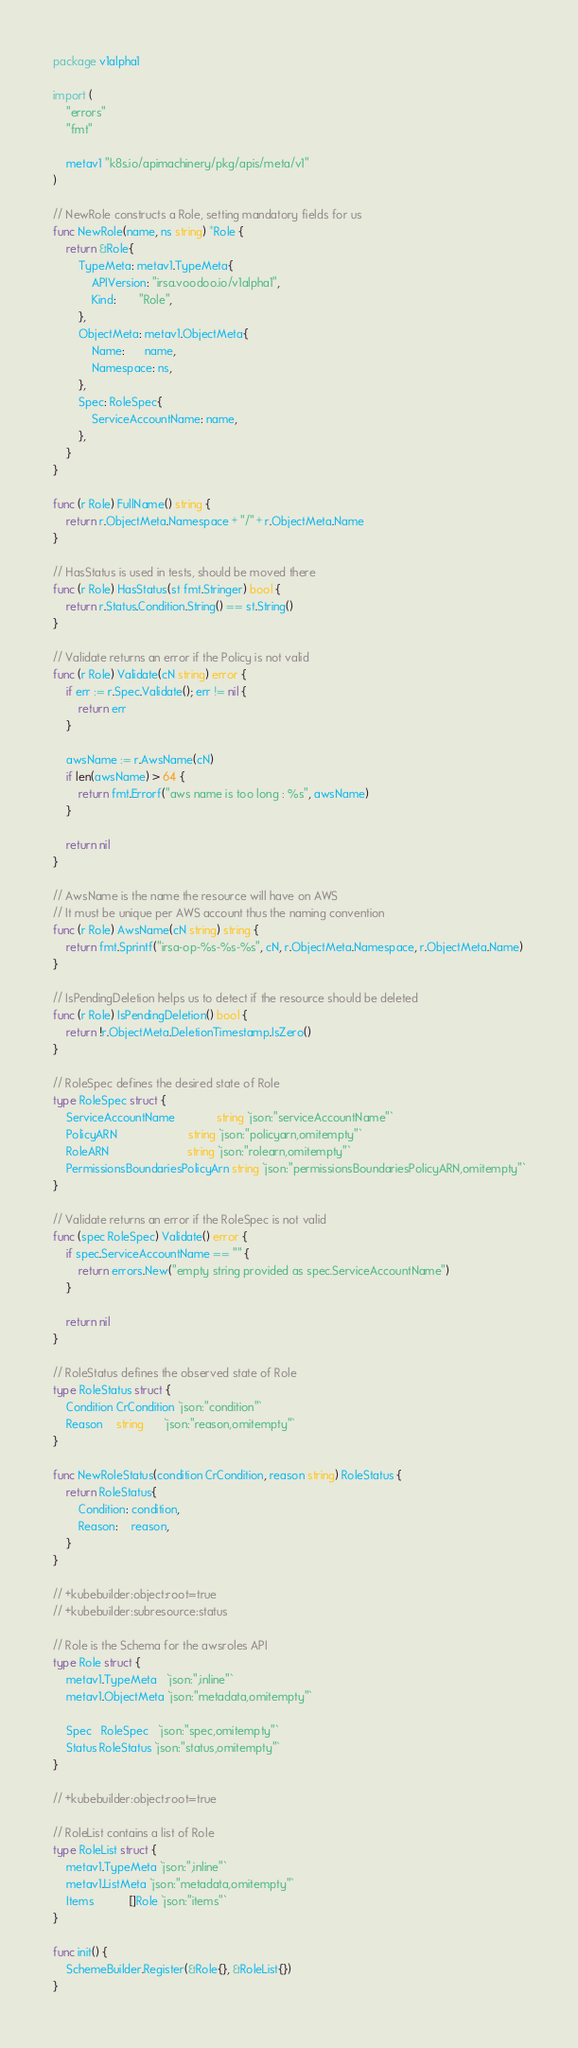Convert code to text. <code><loc_0><loc_0><loc_500><loc_500><_Go_>package v1alpha1

import (
	"errors"
	"fmt"

	metav1 "k8s.io/apimachinery/pkg/apis/meta/v1"
)

// NewRole constructs a Role, setting mandatory fields for us
func NewRole(name, ns string) *Role {
	return &Role{
		TypeMeta: metav1.TypeMeta{
			APIVersion: "irsa.voodoo.io/v1alpha1",
			Kind:       "Role",
		},
		ObjectMeta: metav1.ObjectMeta{
			Name:      name,
			Namespace: ns,
		},
		Spec: RoleSpec{
			ServiceAccountName: name,
		},
	}
}

func (r Role) FullName() string {
	return r.ObjectMeta.Namespace + "/" + r.ObjectMeta.Name
}

// HasStatus is used in tests, should be moved there
func (r Role) HasStatus(st fmt.Stringer) bool {
	return r.Status.Condition.String() == st.String()
}

// Validate returns an error if the Policy is not valid
func (r Role) Validate(cN string) error {
	if err := r.Spec.Validate(); err != nil {
		return err
	}

	awsName := r.AwsName(cN)
	if len(awsName) > 64 {
		return fmt.Errorf("aws name is too long : %s", awsName)
	}

	return nil
}

// AwsName is the name the resource will have on AWS
// It must be unique per AWS account thus the naming convention
func (r Role) AwsName(cN string) string {
	return fmt.Sprintf("irsa-op-%s-%s-%s", cN, r.ObjectMeta.Namespace, r.ObjectMeta.Name)
}

// IsPendingDeletion helps us to detect if the resource should be deleted
func (r Role) IsPendingDeletion() bool {
	return !r.ObjectMeta.DeletionTimestamp.IsZero()
}

// RoleSpec defines the desired state of Role
type RoleSpec struct {
	ServiceAccountName             string `json:"serviceAccountName"`
	PolicyARN                      string `json:"policyarn,omitempty"`
	RoleARN                        string `json:"rolearn,omitempty"`
	PermissionsBoundariesPolicyArn string `json:"permissionsBoundariesPolicyARN,omitempty"`
}

// Validate returns an error if the RoleSpec is not valid
func (spec RoleSpec) Validate() error {
	if spec.ServiceAccountName == "" {
		return errors.New("empty string provided as spec.ServiceAccountName")
	}

	return nil
}

// RoleStatus defines the observed state of Role
type RoleStatus struct {
	Condition CrCondition `json:"condition"`
	Reason    string      `json:"reason,omitempty"`
}

func NewRoleStatus(condition CrCondition, reason string) RoleStatus {
	return RoleStatus{
		Condition: condition,
		Reason:    reason,
	}
}

// +kubebuilder:object:root=true
// +kubebuilder:subresource:status

// Role is the Schema for the awsroles API
type Role struct {
	metav1.TypeMeta   `json:",inline"`
	metav1.ObjectMeta `json:"metadata,omitempty"`

	Spec   RoleSpec   `json:"spec,omitempty"`
	Status RoleStatus `json:"status,omitempty"`
}

// +kubebuilder:object:root=true

// RoleList contains a list of Role
type RoleList struct {
	metav1.TypeMeta `json:",inline"`
	metav1.ListMeta `json:"metadata,omitempty"`
	Items           []Role `json:"items"`
}

func init() {
	SchemeBuilder.Register(&Role{}, &RoleList{})
}
</code> 